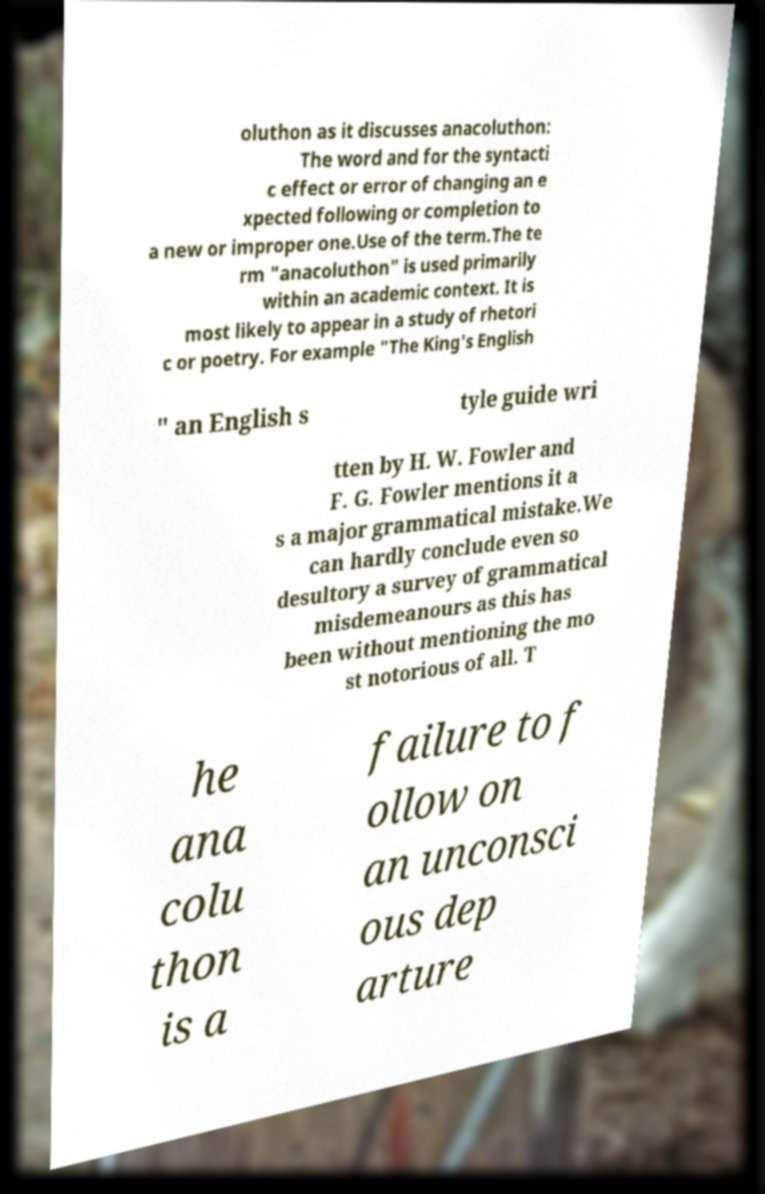What messages or text are displayed in this image? I need them in a readable, typed format. oluthon as it discusses anacoluthon: The word and for the syntacti c effect or error of changing an e xpected following or completion to a new or improper one.Use of the term.The te rm "anacoluthon" is used primarily within an academic context. It is most likely to appear in a study of rhetori c or poetry. For example "The King's English " an English s tyle guide wri tten by H. W. Fowler and F. G. Fowler mentions it a s a major grammatical mistake.We can hardly conclude even so desultory a survey of grammatical misdemeanours as this has been without mentioning the mo st notorious of all. T he ana colu thon is a failure to f ollow on an unconsci ous dep arture 